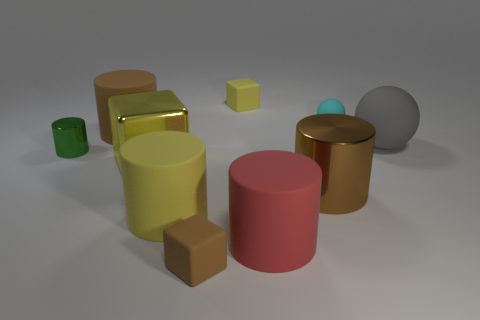Is there any other thing that has the same color as the big metal cylinder?
Your answer should be compact. Yes. Do the cyan object and the yellow rubber thing that is behind the small cyan ball have the same shape?
Your response must be concise. No. The tiny cube behind the brown thing that is left of the small block in front of the small yellow matte block is what color?
Offer a very short reply. Yellow. There is a yellow rubber thing that is behind the tiny green shiny thing; does it have the same shape as the tiny brown rubber object?
Offer a terse response. Yes. What is the material of the red thing?
Ensure brevity in your answer.  Rubber. There is a large rubber object that is right of the big brown object to the right of the yellow block that is behind the gray sphere; what is its shape?
Provide a short and direct response. Sphere. What number of other objects are the same shape as the cyan thing?
Offer a very short reply. 1. There is a big metallic block; is it the same color as the small object that is on the left side of the large brown rubber object?
Provide a short and direct response. No. What number of rubber spheres are there?
Offer a terse response. 2. What number of things are either big green metal cylinders or tiny rubber balls?
Offer a terse response. 1. 